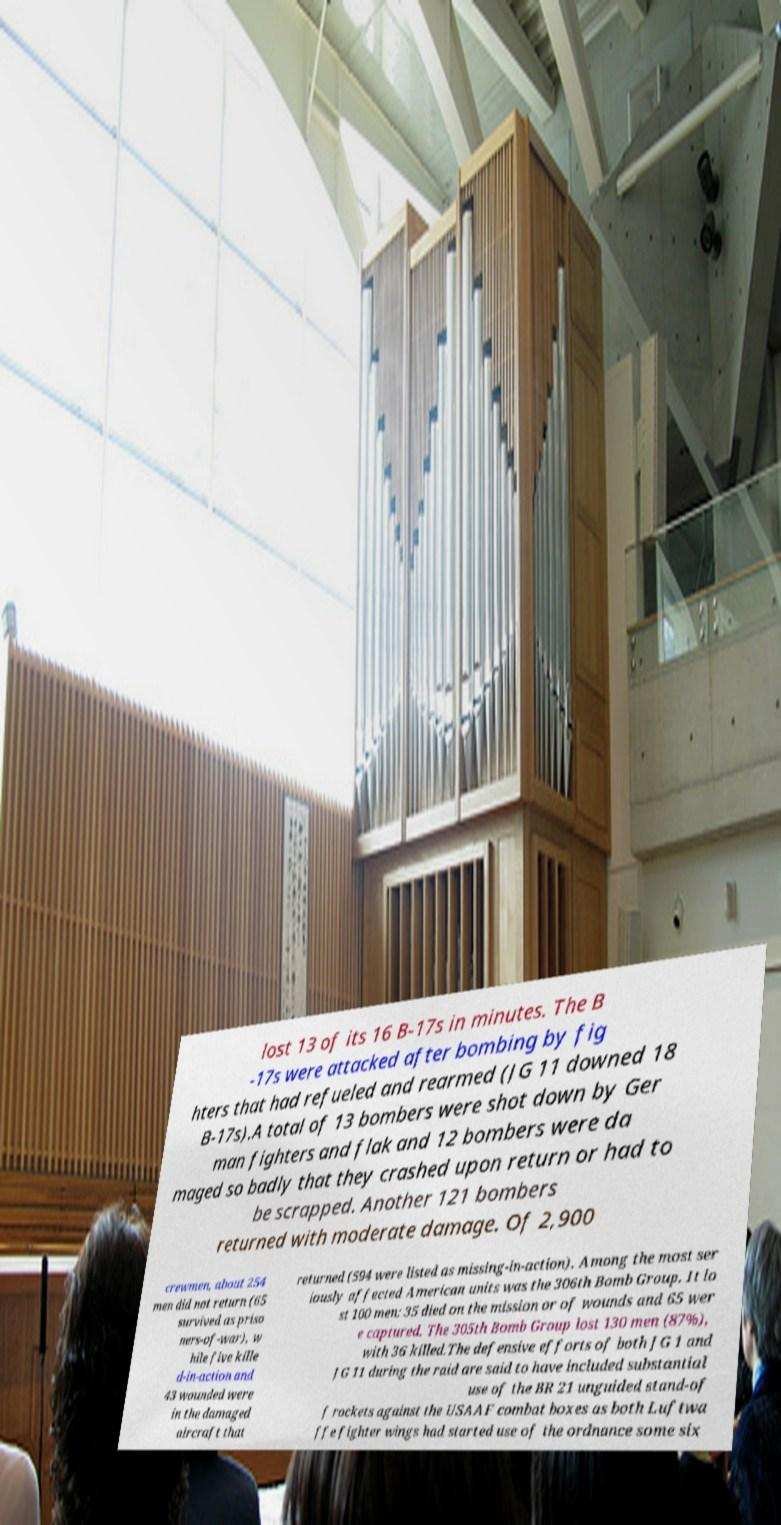Can you accurately transcribe the text from the provided image for me? lost 13 of its 16 B-17s in minutes. The B -17s were attacked after bombing by fig hters that had refueled and rearmed (JG 11 downed 18 B-17s).A total of 13 bombers were shot down by Ger man fighters and flak and 12 bombers were da maged so badly that they crashed upon return or had to be scrapped. Another 121 bombers returned with moderate damage. Of 2,900 crewmen, about 254 men did not return (65 survived as priso ners-of-war), w hile five kille d-in-action and 43 wounded were in the damaged aircraft that returned (594 were listed as missing-in-action). Among the most ser iously affected American units was the 306th Bomb Group. It lo st 100 men: 35 died on the mission or of wounds and 65 wer e captured. The 305th Bomb Group lost 130 men (87%), with 36 killed.The defensive efforts of both JG 1 and JG 11 during the raid are said to have included substantial use of the BR 21 unguided stand-of f rockets against the USAAF combat boxes as both Luftwa ffe fighter wings had started use of the ordnance some six 